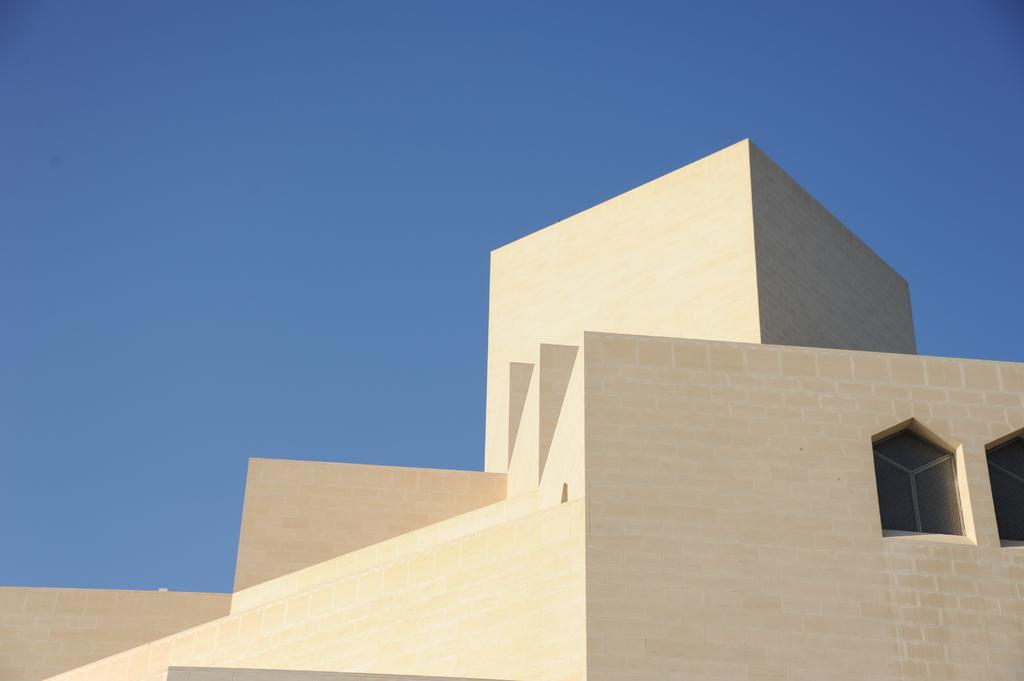What is the main structure visible in the image? There is a building in the image. What feature can be seen on the building? The building has windows. How many pizzas can be seen being ordered by the building in the image? There is no indication of pizzas or an order in the image; it only features a building with windows. 